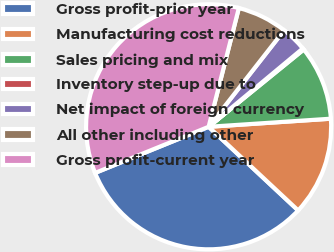Convert chart. <chart><loc_0><loc_0><loc_500><loc_500><pie_chart><fcel>Gross profit-prior year<fcel>Manufacturing cost reductions<fcel>Sales pricing and mix<fcel>Inventory step-up due to<fcel>Net impact of foreign currency<fcel>All other including other<fcel>Gross profit-current year<nl><fcel>31.9%<fcel>13.01%<fcel>9.81%<fcel>0.18%<fcel>3.39%<fcel>6.6%<fcel>35.11%<nl></chart> 